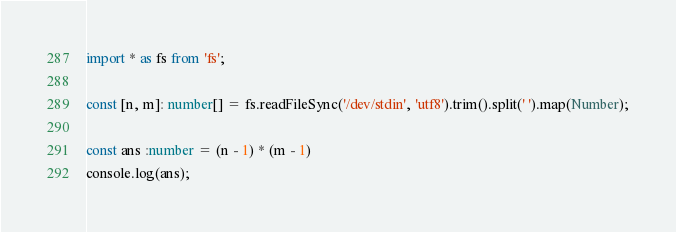<code> <loc_0><loc_0><loc_500><loc_500><_TypeScript_>import * as fs from 'fs';

const [n, m]: number[] = fs.readFileSync('/dev/stdin', 'utf8').trim().split(' ').map(Number);

const ans :number = (n - 1) * (m - 1)
console.log(ans);


</code> 